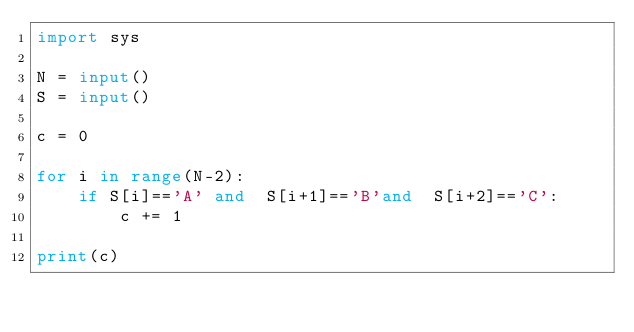Convert code to text. <code><loc_0><loc_0><loc_500><loc_500><_Python_>import sys

N = input()
S = input()

c = 0

for i in range(N-2):
    if S[i]=='A' and  S[i+1]=='B'and  S[i+2]=='C':
        c += 1

print(c)</code> 